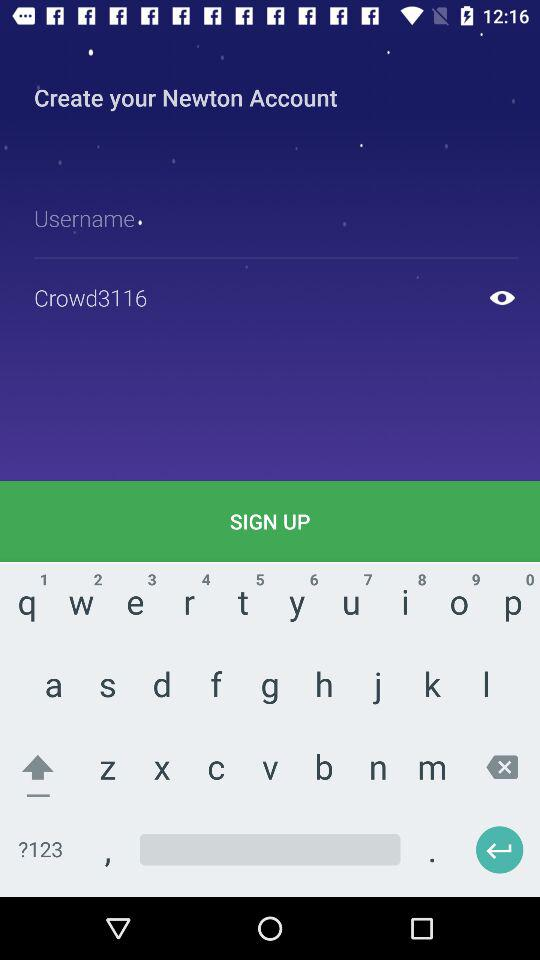Do I need a credit card for the free trial? For the free trial, no credit card is required. 